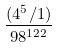Convert formula to latex. <formula><loc_0><loc_0><loc_500><loc_500>\frac { ( 4 ^ { 5 } / 1 ) } { 9 8 ^ { 1 2 2 } }</formula> 